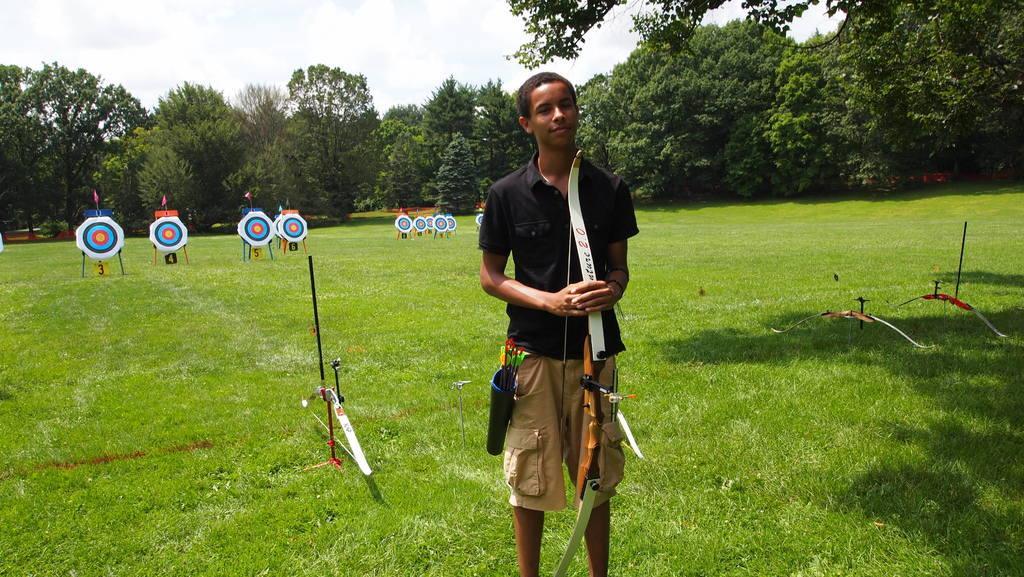Could you give a brief overview of what you see in this image? In this image we can see a person wearing black color shirt, brown color short holding archer in his hands and at the background of the image there are some target archery, there are some trees and clear sky. 